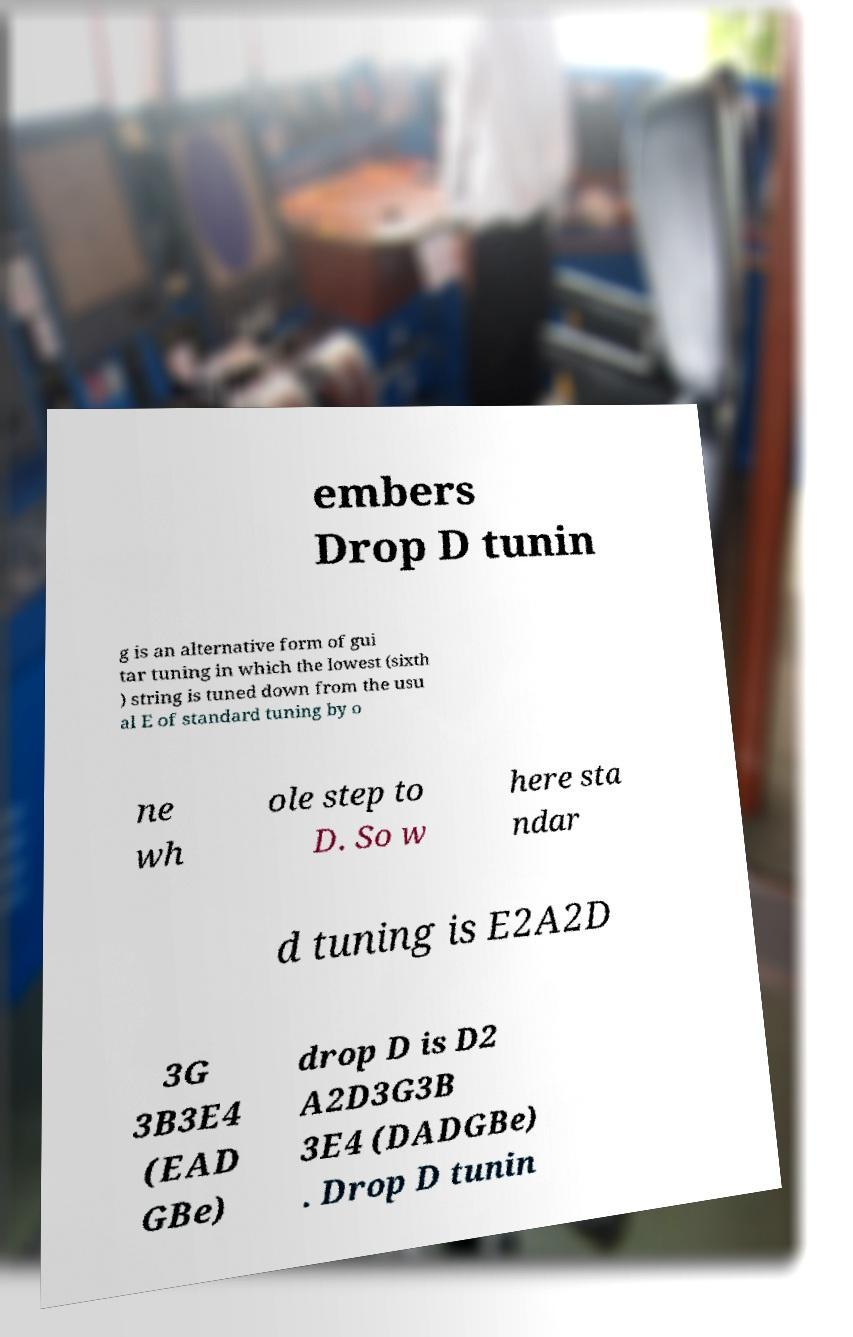Could you assist in decoding the text presented in this image and type it out clearly? embers Drop D tunin g is an alternative form of gui tar tuning in which the lowest (sixth ) string is tuned down from the usu al E of standard tuning by o ne wh ole step to D. So w here sta ndar d tuning is E2A2D 3G 3B3E4 (EAD GBe) drop D is D2 A2D3G3B 3E4 (DADGBe) . Drop D tunin 